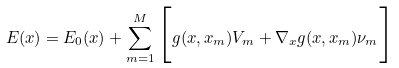Convert formula to latex. <formula><loc_0><loc_0><loc_500><loc_500>E ( x ) = E _ { 0 } ( x ) + \sum _ { m = 1 } ^ { M } \Big { [ } g ( x , x _ { m } ) V _ { m } + \nabla _ { x } g ( x , x _ { m } ) \nu _ { m } \Big { ] }</formula> 